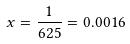Convert formula to latex. <formula><loc_0><loc_0><loc_500><loc_500>x = \frac { 1 } { 6 2 5 } = 0 . 0 0 1 6</formula> 